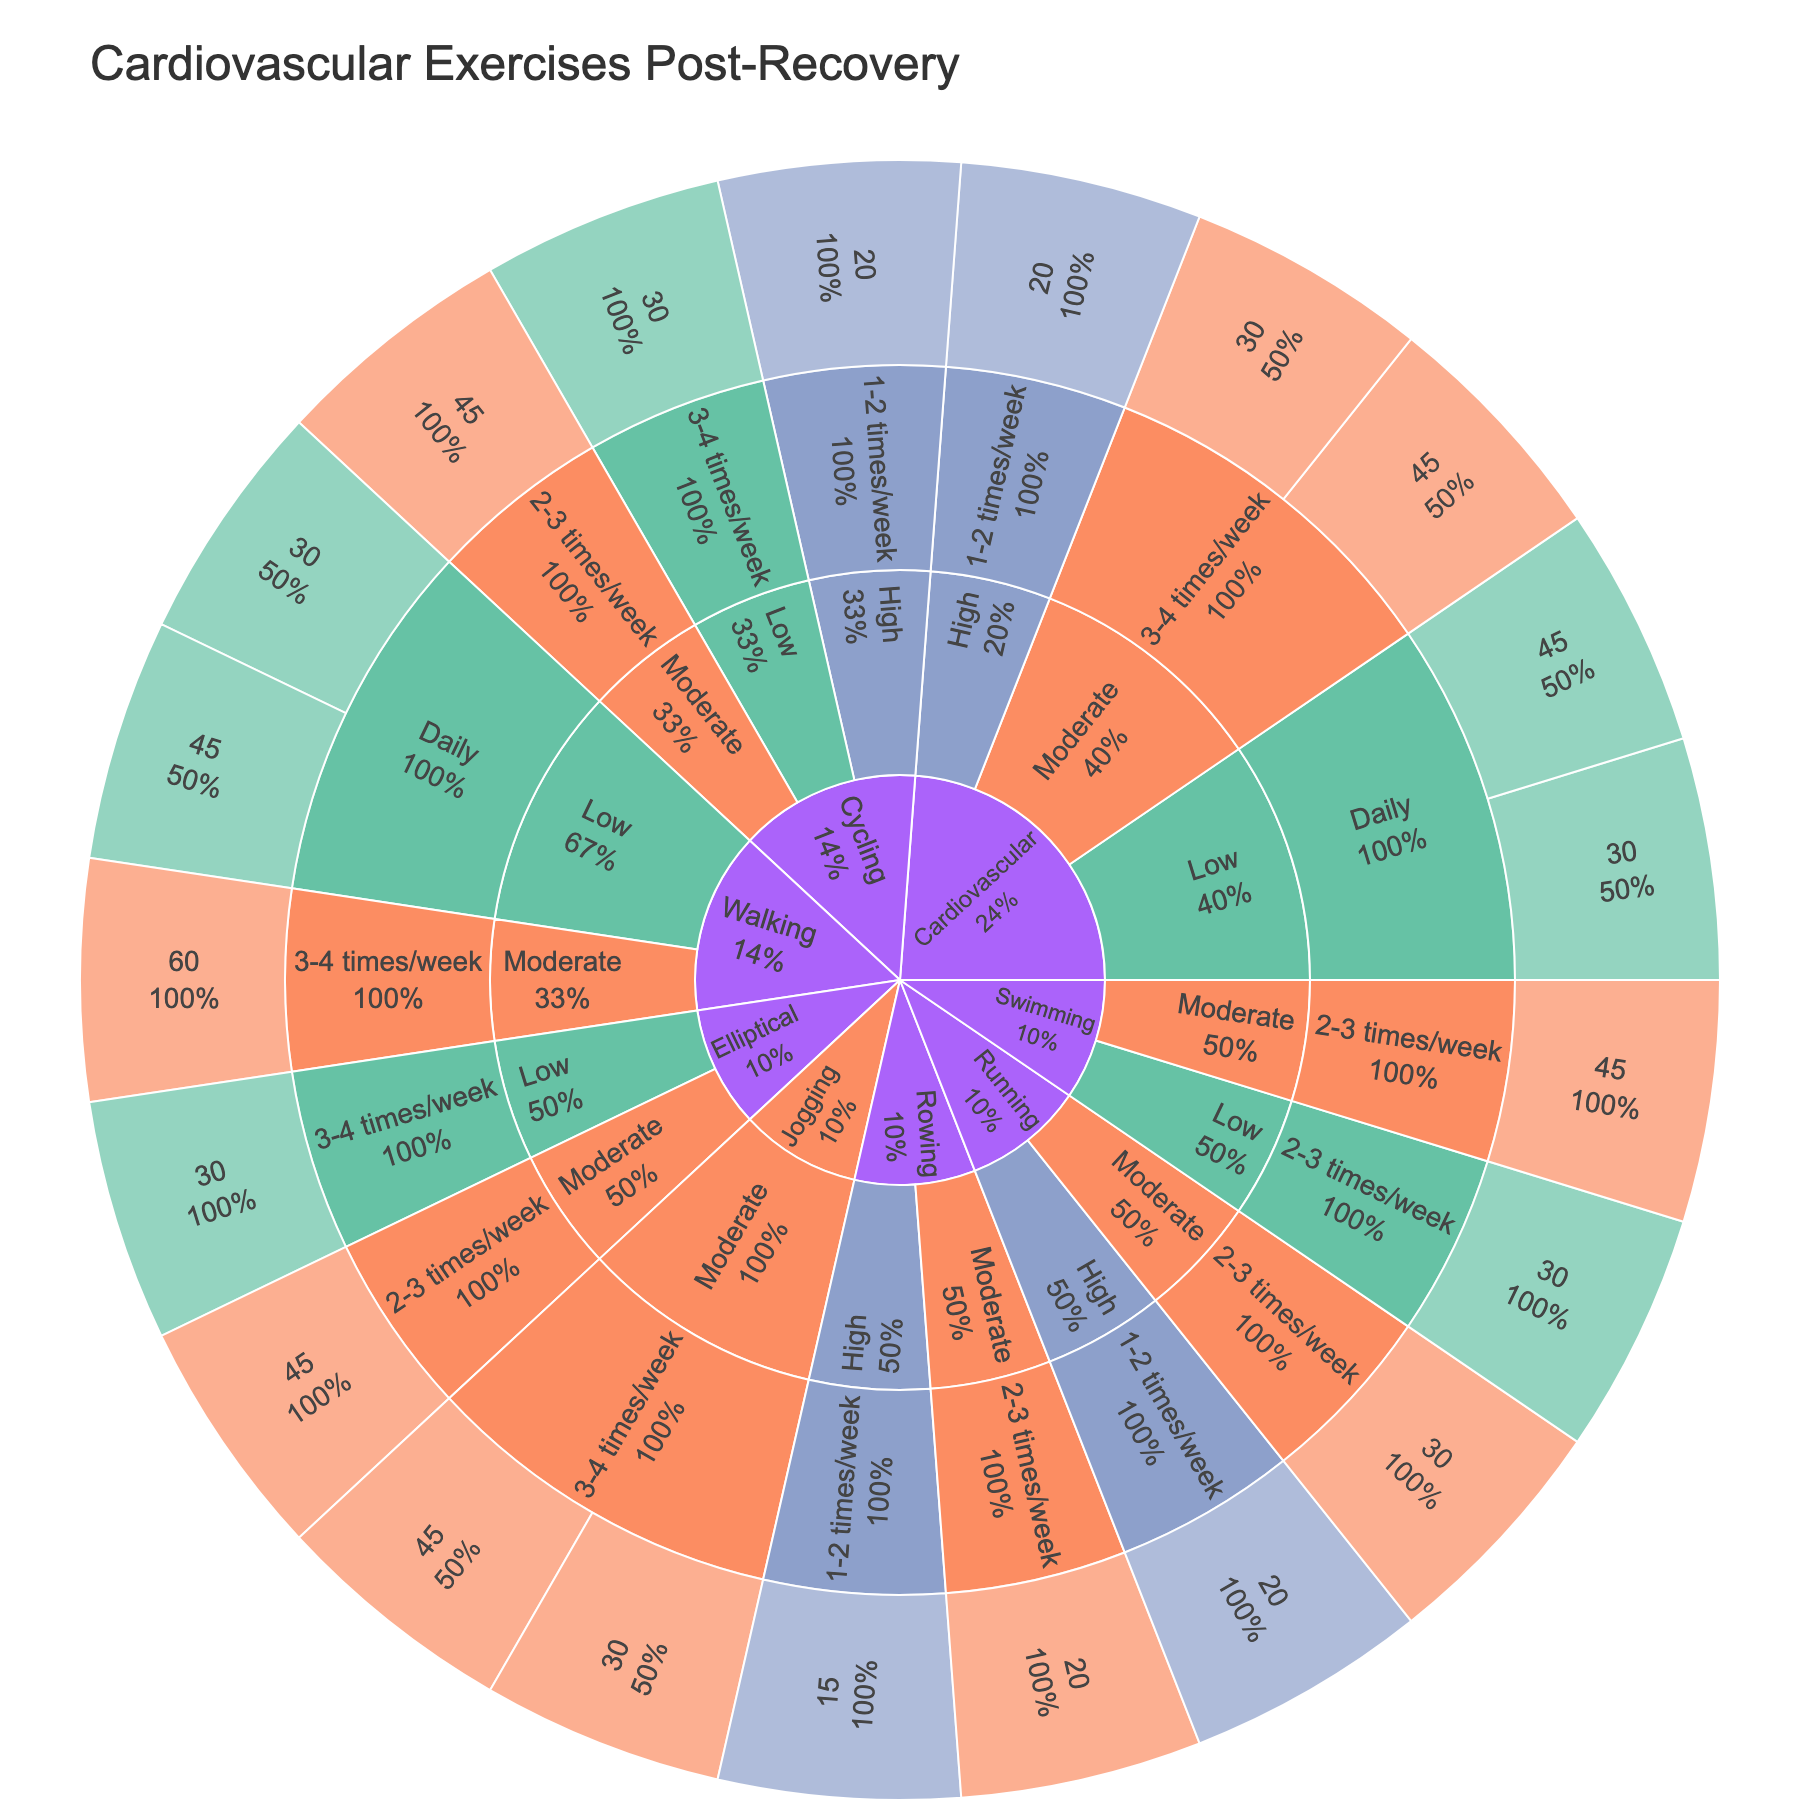What is the title of the sunburst plot? The title is placed at the top of the sunburst plot and provides an overview of the data displayed. By reading the title, one can understand the broad context of the visualized data.
Answer: Cardiovascular Exercises Post-Recovery What color is used to represent 'Moderate' intensity exercises in the plot? The color used for different intensities can be identified in the plot by looking at the color key or legend. The 'Moderate' intensity is associated with an orange-like color.
Answer: Orange How many exercise types are displayed in the plot? By looking at the outermost rings of the sunburst plot, you can count the distinct exercise types that are mentioned. Each segment representing 'Exercise Type' is counted.
Answer: 8 Which exercise types are performed daily? By focusing on the daily frequency segment of each exercise type, one can identify which exercise types occur daily. Check for the presence of 'Daily' segments under each 'Exercise Type'.
Answer: Cardiovascular, Walking What is the most common intensity level for 'Cycling'? Look at the 'Cycling' segments and observe the different intensities associated with them. Determine which intensity appears most frequently.
Answer: Moderate How many segments represent 'High' intensity exercises with a frequency of 1-2 times/week? Segments colored for 'High' intensity and marked with '1-2 times/week' frequency need to be counted. Each of these segments should be distinguished from 'Moderate' or 'Low' intensity segments.
Answer: 3 Which 'Exercise Type' has the longest duration for 'Moderate' intensity exercises performed 3-4 times/week? Identify the 'Moderate' intensity exercises with the frequency of 3-4 times/week. Among these segments, find the one with the longest duration.
Answer: Walking Is 'Rowing' ever performed daily in this dataset? Check the segments labeled 'Rowing' to see if any of these have a frequency marked as 'Daily'. Only the presence of a 'Daily' frequency segment under 'Rowing' should be considered.
Answer: No How many different frequency categories are present in the plot? Look at all the segments branching out from each exercise type and list the unique categories like 'Daily', '2-3 times/week', '3-4 times/week', etc. Count these distinct categories.
Answer: 4 Which exercise type has no 'Low' intensity option? Look for exercise types and check whether there is a missing segment for 'Low' intensity within their categories. The absence of a 'Low' category for a specific exercise type concludes this inquiry.
Answer: Rowing 